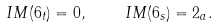<formula> <loc_0><loc_0><loc_500><loc_500>I M ( 6 _ { t } ) = 0 , \quad I M ( 6 _ { s } ) = 2 _ { a } .</formula> 